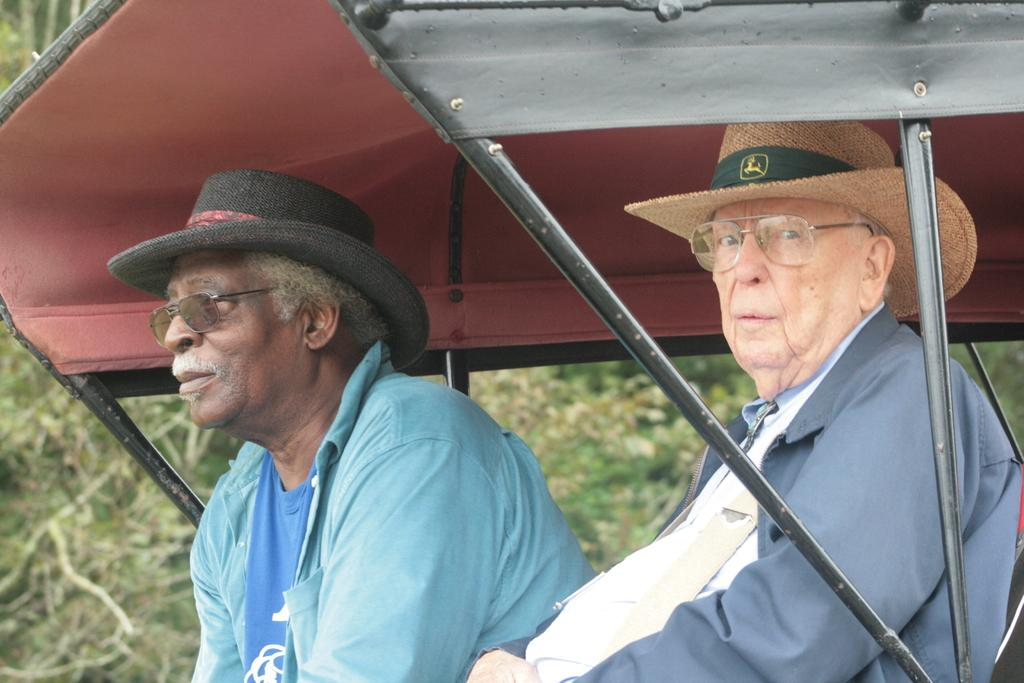How many people are in the image? There are two persons in the image. What are the persons wearing on their faces? Both persons are wearing spectacles. What are the persons wearing on their heads? Both persons are wearing hats. What are the persons sitting in? The two persons are sitting in a cart. What can be seen in the background of the image? The background of the image is slightly blurred, and green trees are visible. What are the girls in the image afraid of? There are no girls present in the image, and therefore no fear can be attributed to them. Who is the servant in the image? There is no servant present in the image. 